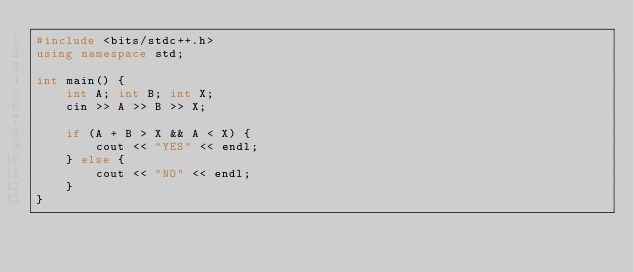Convert code to text. <code><loc_0><loc_0><loc_500><loc_500><_C++_>#include <bits/stdc++.h>
using namespace std;

int main() {
    int A; int B; int X;
    cin >> A >> B >> X;

    if (A + B > X && A < X) {
        cout << "YES" << endl;
    } else {
        cout << "NO" << endl;
    }
}
</code> 